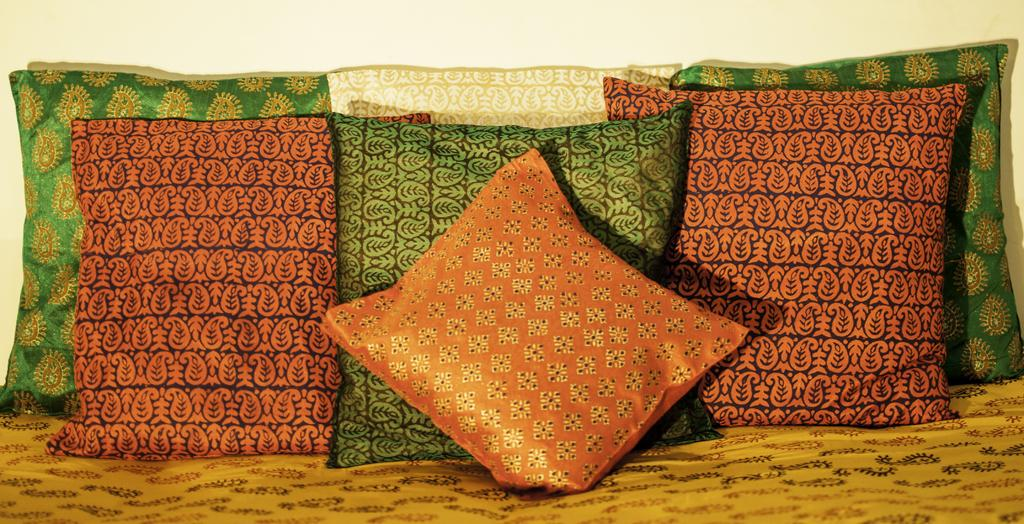What objects are present in the image in large quantities? There are many pillows in the image. What distinguishes the pillows from one another? The pillows have different colors. On what surface are the pillows placed? The pillows are on a surface. What type of pipe can be seen in the image? There is no pipe present in the image; it features many pillows with different colors. How long does it take for the crayon to melt in the image? There is no crayon present in the image, so it is not possible to determine how long it would take for it to melt. 